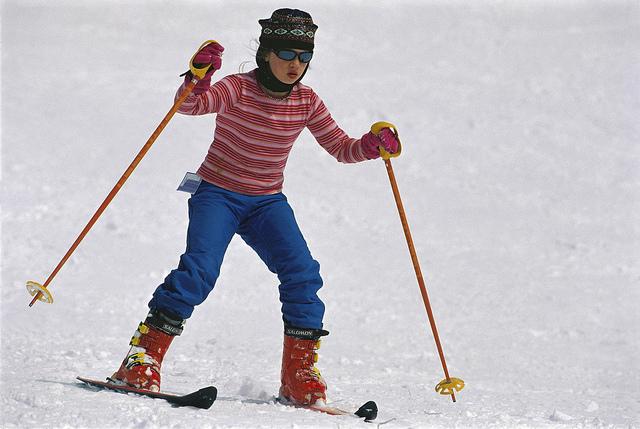What is the boy doing?
Concise answer only. Skiing. What is the boy standing on?
Short answer required. Skis. What color are this boys pants?
Be succinct. Blue. 